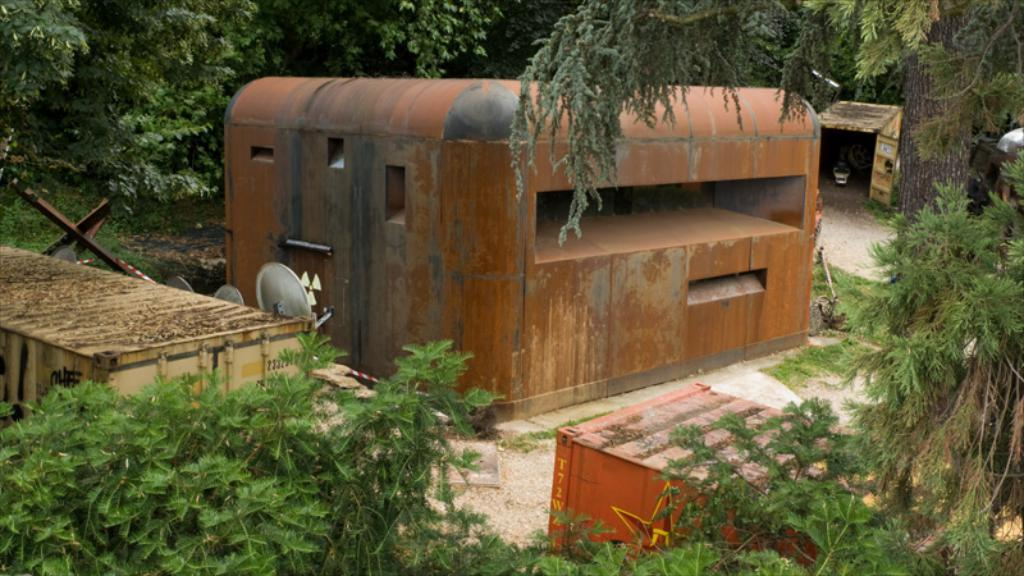What type of objects can be seen in the image? There are containers in the image. What natural elements are present in the image? There are trees and grass visible in the image. What else can be found on the ground in the image? There are other objects on the ground in the image. How many hands are visible in the image? There are no hands visible in the image. Are there any dinosaurs present in the image? There are no dinosaurs present in the image. 